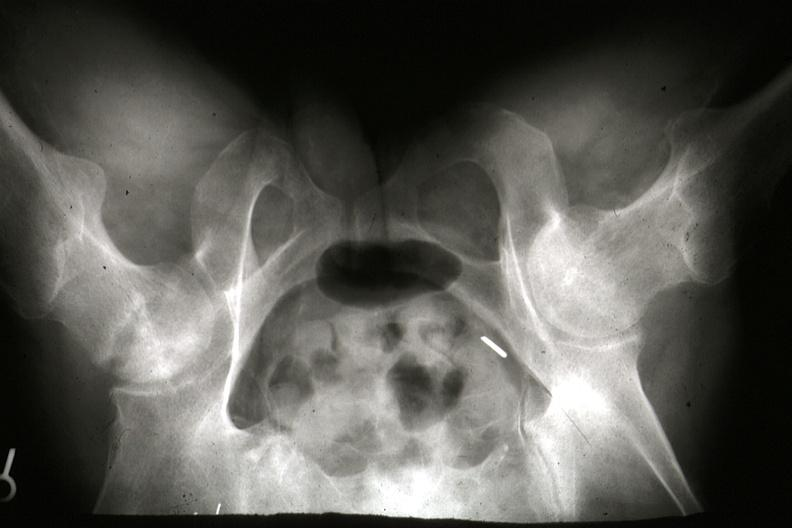what is present?
Answer the question using a single word or phrase. Joints 